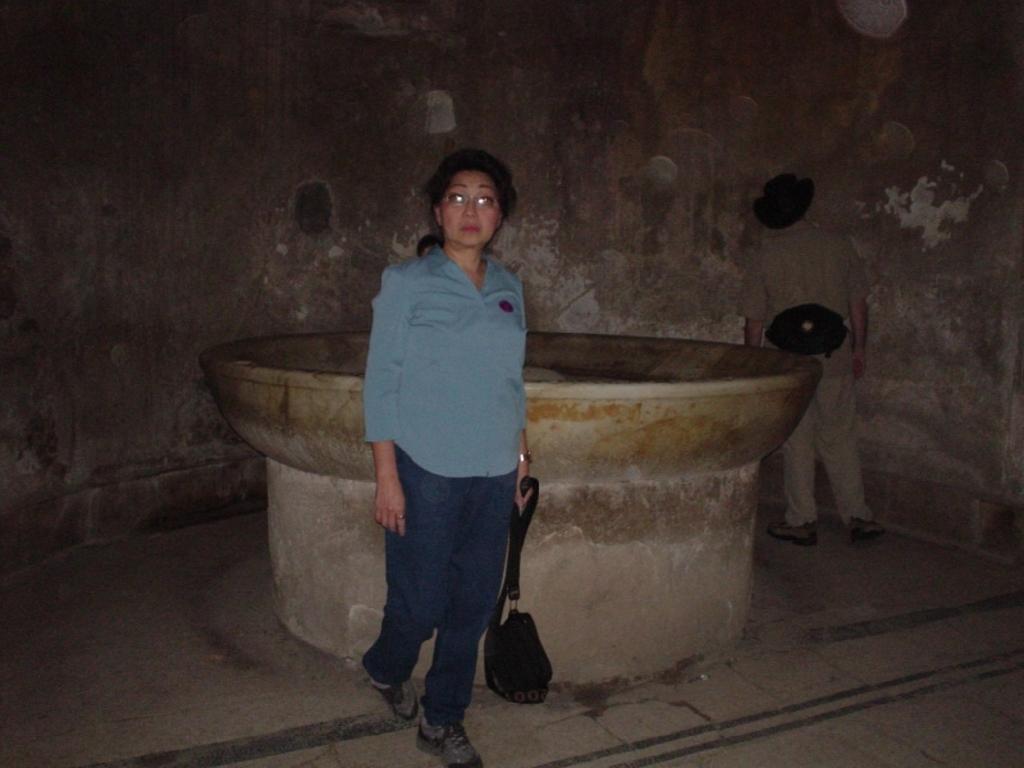Could you give a brief overview of what you see in this image? In this image we can see two people standing. The lady standing in the center is holding a bag. In the background there is a fountain and a wall. 